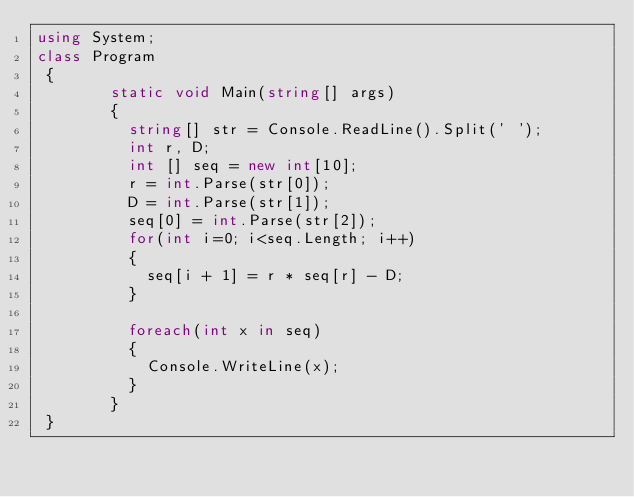<code> <loc_0><loc_0><loc_500><loc_500><_C#_>using System;
class Program
 {
        static void Main(string[] args)
        {
          string[] str = Console.ReadLine().Split(' ');
          int r, D;
          int [] seq = new int[10];
          r = int.Parse(str[0]);  
          D = int.Parse(str[1]);
          seq[0] = int.Parse(str[2]);
          for(int i=0; i<seq.Length; i++)
          {
            seq[i + 1] = r * seq[r] - D;
          }
          
          foreach(int x in seq)
          {
            Console.WriteLine(x);
          }   
        }
 }</code> 